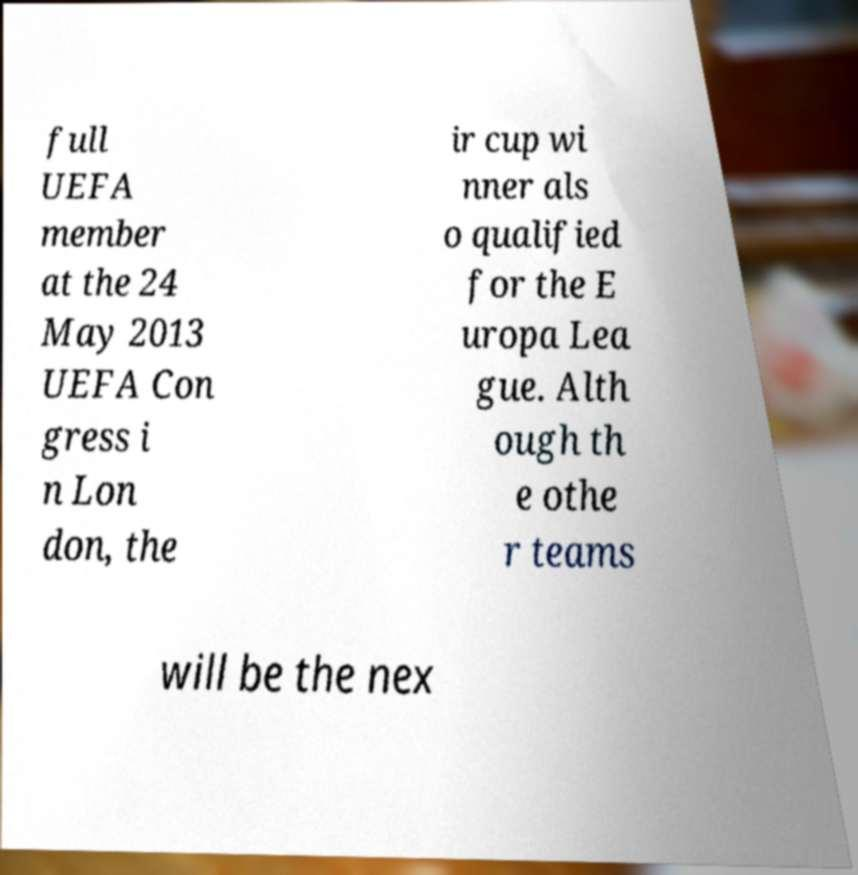Could you assist in decoding the text presented in this image and type it out clearly? full UEFA member at the 24 May 2013 UEFA Con gress i n Lon don, the ir cup wi nner als o qualified for the E uropa Lea gue. Alth ough th e othe r teams will be the nex 